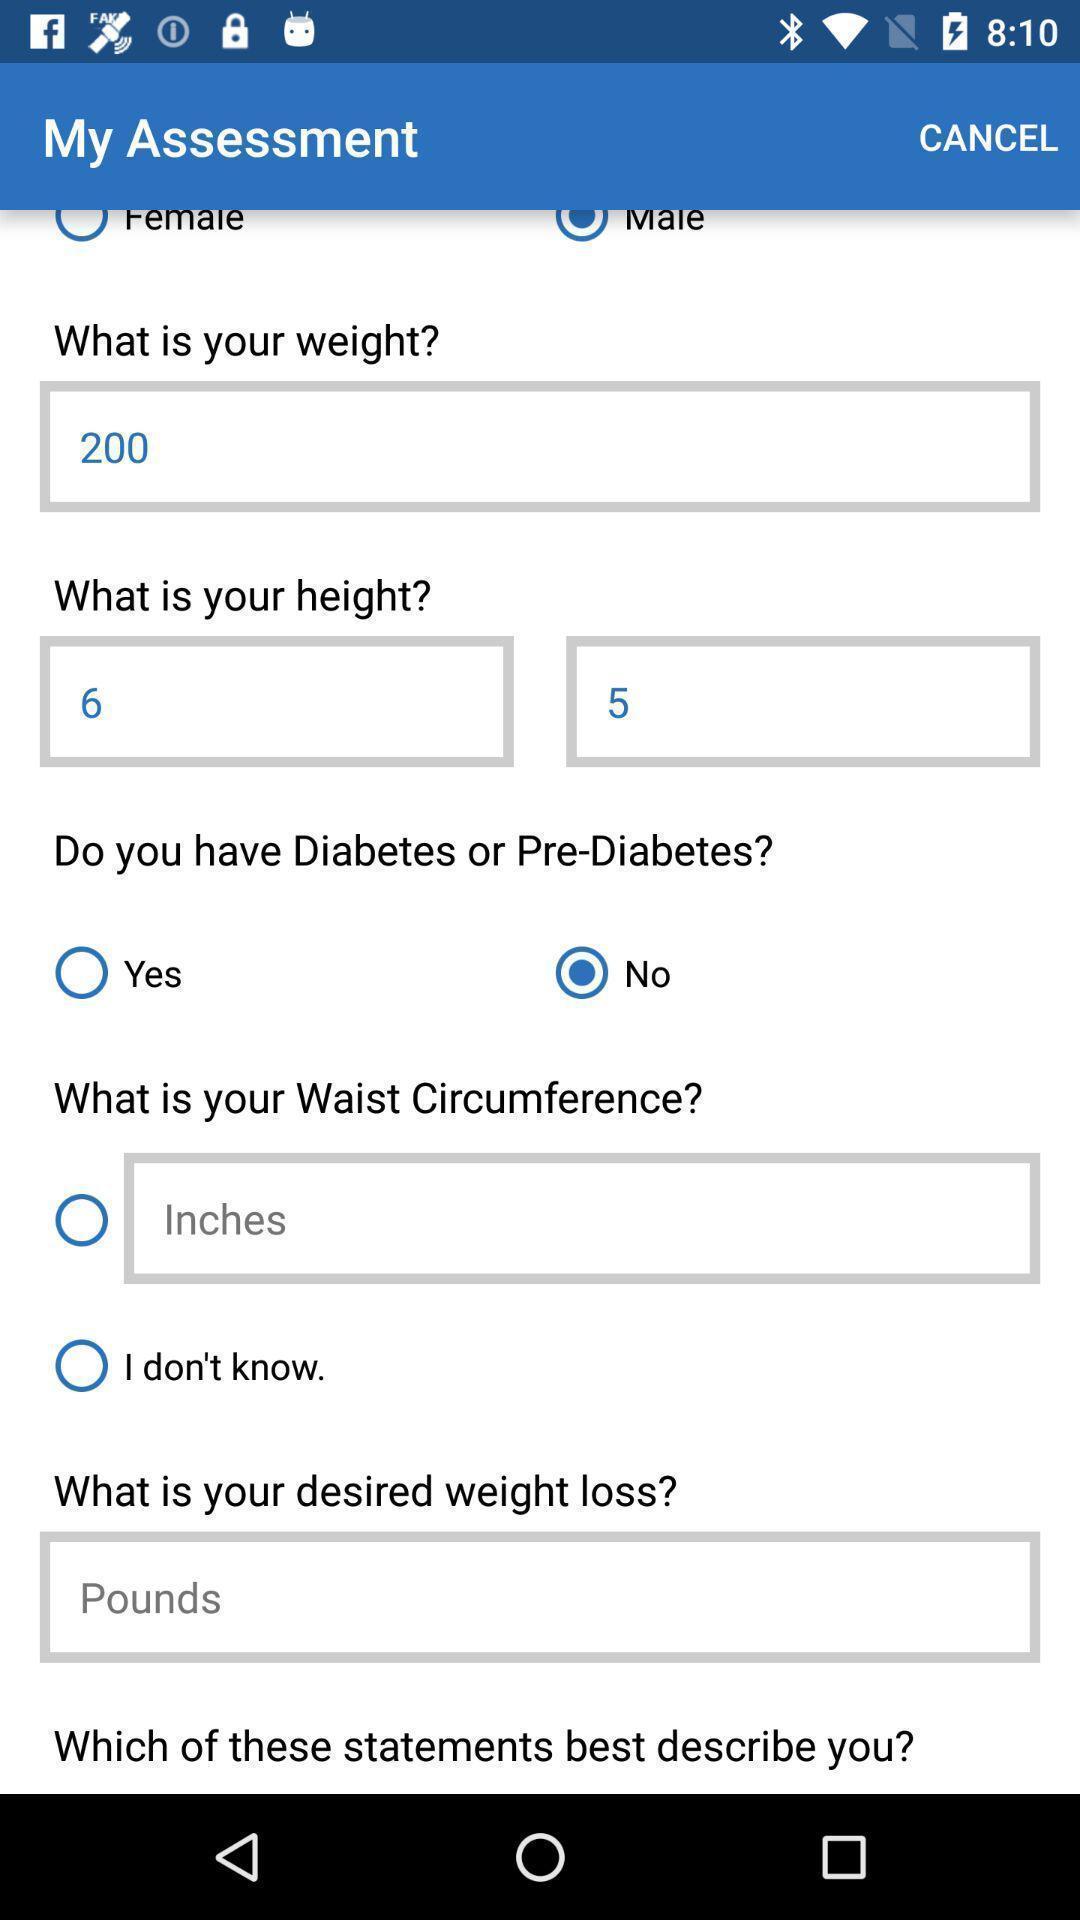Tell me what you see in this picture. Page showing different options for weight loss. 